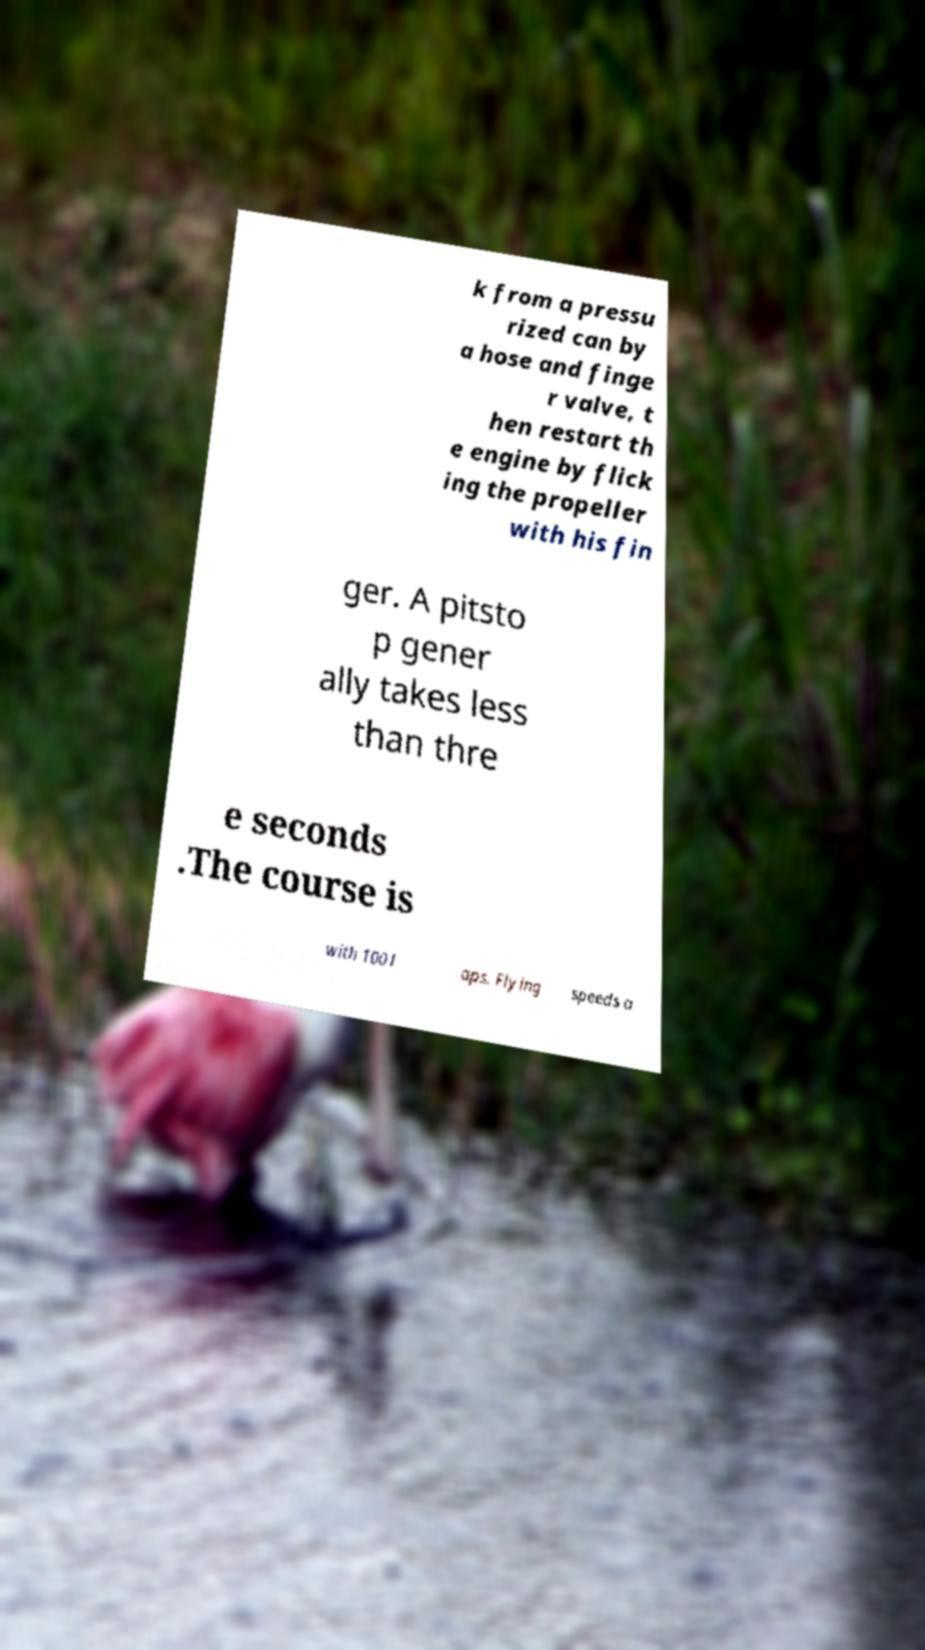Please identify and transcribe the text found in this image. k from a pressu rized can by a hose and finge r valve, t hen restart th e engine by flick ing the propeller with his fin ger. A pitsto p gener ally takes less than thre e seconds .The course is with 100 l aps. Flying speeds a 